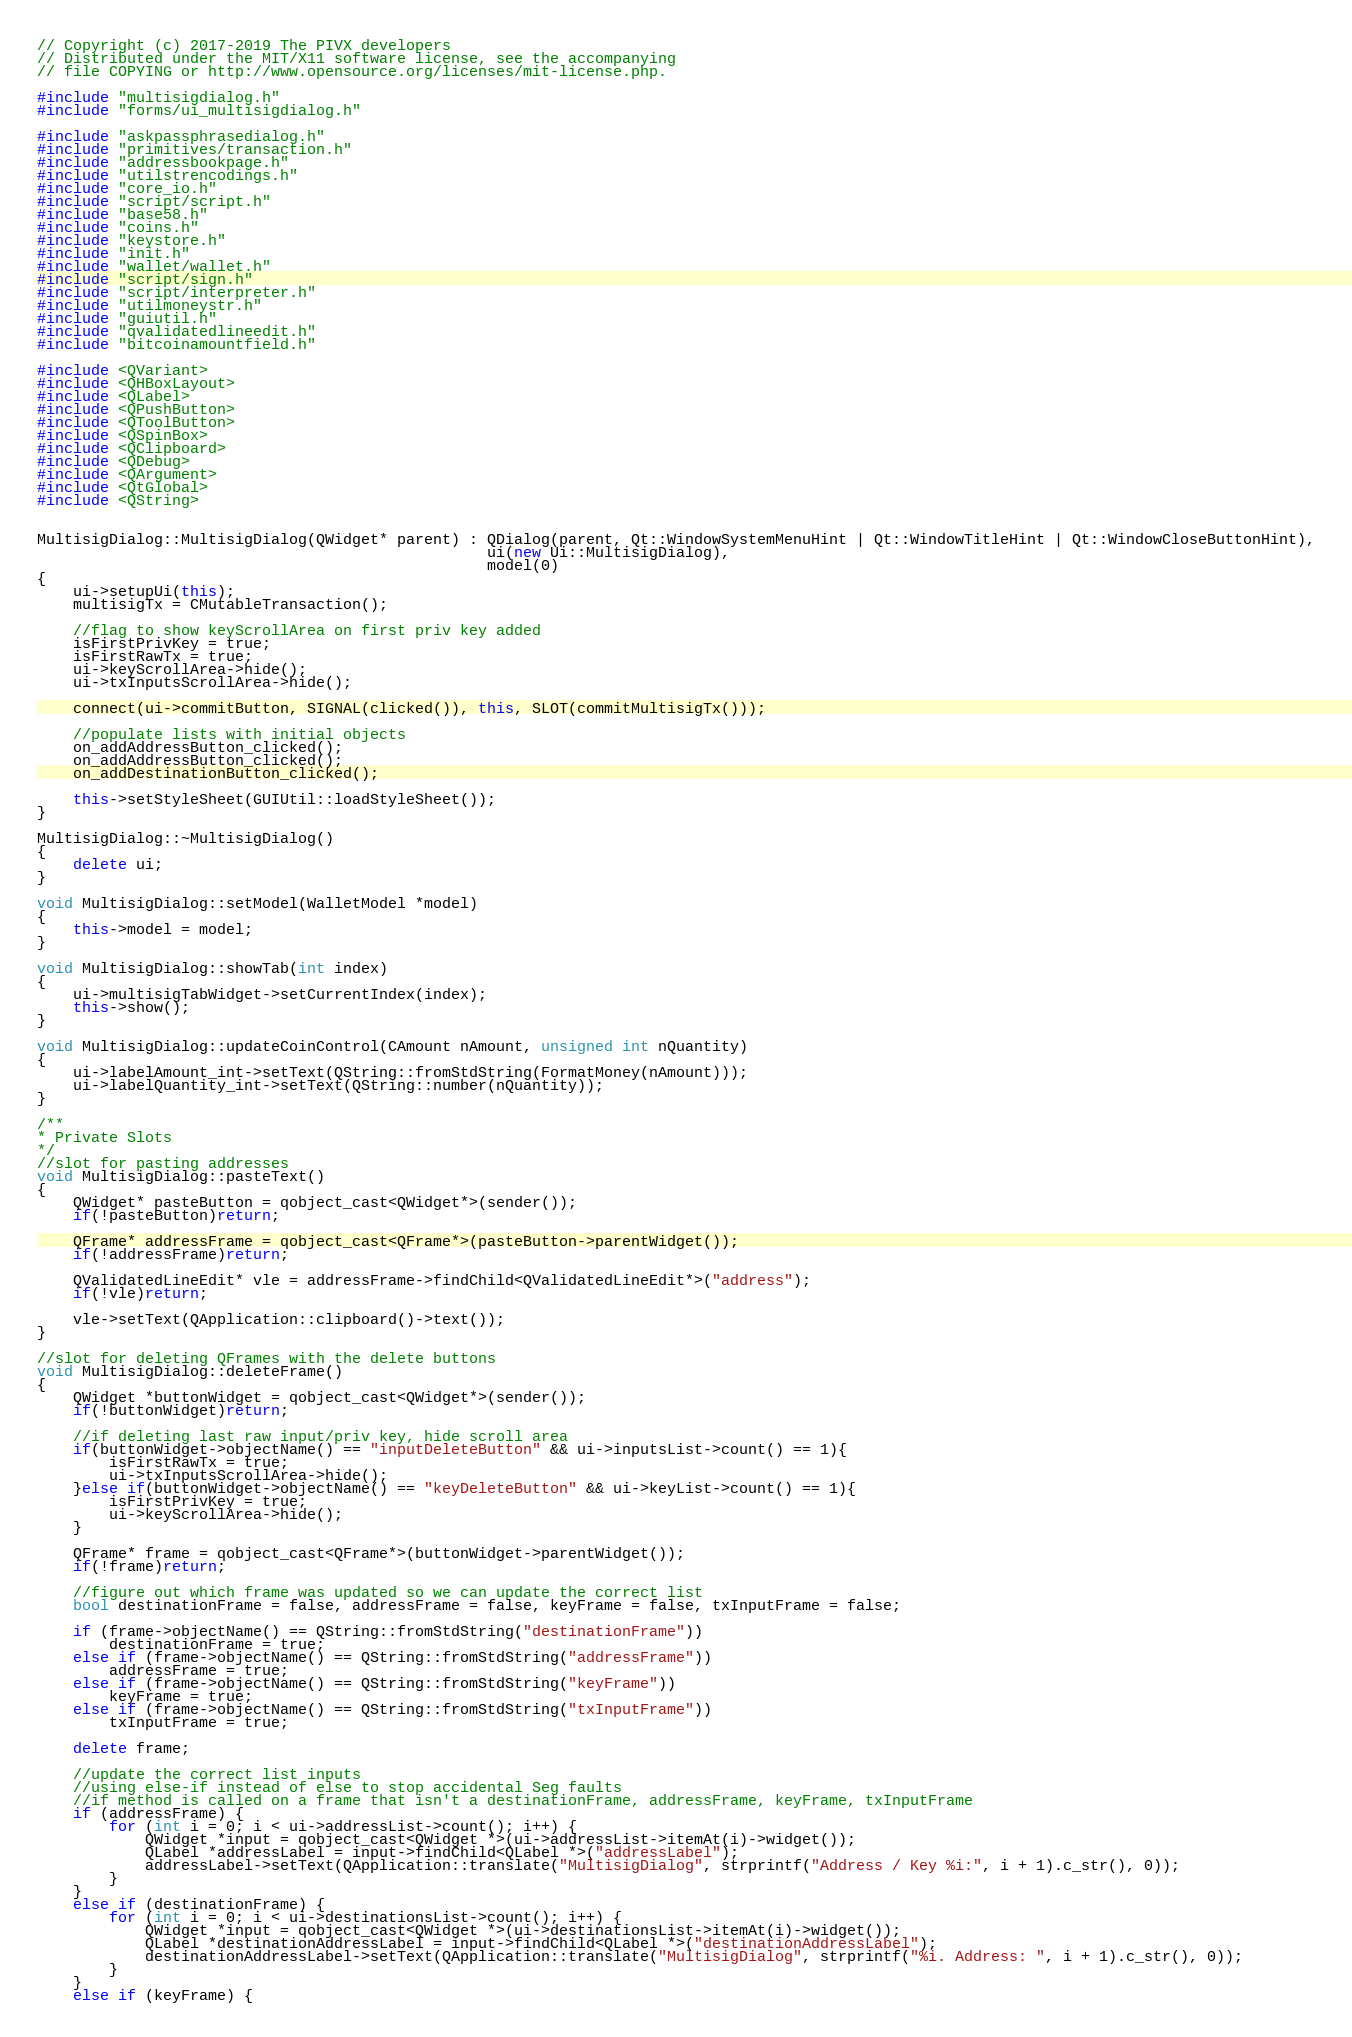<code> <loc_0><loc_0><loc_500><loc_500><_C++_>// Copyright (c) 2017-2019 The PIVX developers
// Distributed under the MIT/X11 software license, see the accompanying
// file COPYING or http://www.opensource.org/licenses/mit-license.php.

#include "multisigdialog.h"
#include "forms/ui_multisigdialog.h"

#include "askpassphrasedialog.h"
#include "primitives/transaction.h"
#include "addressbookpage.h"
#include "utilstrencodings.h"
#include "core_io.h"
#include "script/script.h"
#include "base58.h"
#include "coins.h"
#include "keystore.h"
#include "init.h"
#include "wallet/wallet.h"
#include "script/sign.h"
#include "script/interpreter.h"
#include "utilmoneystr.h"
#include "guiutil.h"
#include "qvalidatedlineedit.h"
#include "bitcoinamountfield.h"

#include <QVariant>
#include <QHBoxLayout>
#include <QLabel>
#include <QPushButton>
#include <QToolButton>
#include <QSpinBox>
#include <QClipboard>
#include <QDebug>
#include <QArgument>
#include <QtGlobal>
#include <QString>


MultisigDialog::MultisigDialog(QWidget* parent) : QDialog(parent, Qt::WindowSystemMenuHint | Qt::WindowTitleHint | Qt::WindowCloseButtonHint),
                                                  ui(new Ui::MultisigDialog),
                                                  model(0)
{
    ui->setupUi(this);
    multisigTx = CMutableTransaction();

    //flag to show keyScrollArea on first priv key added
    isFirstPrivKey = true;
    isFirstRawTx = true;
    ui->keyScrollArea->hide();
    ui->txInputsScrollArea->hide();

    connect(ui->commitButton, SIGNAL(clicked()), this, SLOT(commitMultisigTx()));

    //populate lists with initial objects
    on_addAddressButton_clicked();
    on_addAddressButton_clicked();
    on_addDestinationButton_clicked();

    this->setStyleSheet(GUIUtil::loadStyleSheet());
}

MultisigDialog::~MultisigDialog()
{
    delete ui;
}

void MultisigDialog::setModel(WalletModel *model)
{
    this->model = model;
}

void MultisigDialog::showTab(int index)
{
    ui->multisigTabWidget->setCurrentIndex(index);
    this->show();
}

void MultisigDialog::updateCoinControl(CAmount nAmount, unsigned int nQuantity)
{
    ui->labelAmount_int->setText(QString::fromStdString(FormatMoney(nAmount)));
    ui->labelQuantity_int->setText(QString::number(nQuantity));
}

/**
* Private Slots
*/
//slot for pasting addresses
void MultisigDialog::pasteText()
{
    QWidget* pasteButton = qobject_cast<QWidget*>(sender());
    if(!pasteButton)return;

    QFrame* addressFrame = qobject_cast<QFrame*>(pasteButton->parentWidget());
    if(!addressFrame)return;

    QValidatedLineEdit* vle = addressFrame->findChild<QValidatedLineEdit*>("address");
    if(!vle)return;

    vle->setText(QApplication::clipboard()->text());
}

//slot for deleting QFrames with the delete buttons
void MultisigDialog::deleteFrame()
{
    QWidget *buttonWidget = qobject_cast<QWidget*>(sender());
    if(!buttonWidget)return;

    //if deleting last raw input/priv key, hide scroll area
    if(buttonWidget->objectName() == "inputDeleteButton" && ui->inputsList->count() == 1){
        isFirstRawTx = true;
        ui->txInputsScrollArea->hide();
    }else if(buttonWidget->objectName() == "keyDeleteButton" && ui->keyList->count() == 1){
        isFirstPrivKey = true;
        ui->keyScrollArea->hide();
    }

    QFrame* frame = qobject_cast<QFrame*>(buttonWidget->parentWidget());
    if(!frame)return;

    //figure out which frame was updated so we can update the correct list
    bool destinationFrame = false, addressFrame = false, keyFrame = false, txInputFrame = false;

    if (frame->objectName() == QString::fromStdString("destinationFrame"))
        destinationFrame = true;
    else if (frame->objectName() == QString::fromStdString("addressFrame"))
        addressFrame = true;
    else if (frame->objectName() == QString::fromStdString("keyFrame"))
        keyFrame = true;
    else if (frame->objectName() == QString::fromStdString("txInputFrame"))
        txInputFrame = true;

    delete frame;

    //update the correct list inputs
    //using else-if instead of else to stop accidental Seg faults
    //if method is called on a frame that isn't a destinationFrame, addressFrame, keyFrame, txInputFrame
    if (addressFrame) {
        for (int i = 0; i < ui->addressList->count(); i++) {
            QWidget *input = qobject_cast<QWidget *>(ui->addressList->itemAt(i)->widget());
            QLabel *addressLabel = input->findChild<QLabel *>("addressLabel");
            addressLabel->setText(QApplication::translate("MultisigDialog", strprintf("Address / Key %i:", i + 1).c_str(), 0));
        }
    }
    else if (destinationFrame) {
        for (int i = 0; i < ui->destinationsList->count(); i++) {
            QWidget *input = qobject_cast<QWidget *>(ui->destinationsList->itemAt(i)->widget());
            QLabel *destinationAddressLabel = input->findChild<QLabel *>("destinationAddressLabel");
            destinationAddressLabel->setText(QApplication::translate("MultisigDialog", strprintf("%i. Address: ", i + 1).c_str(), 0));
        }
    }
    else if (keyFrame) {</code> 